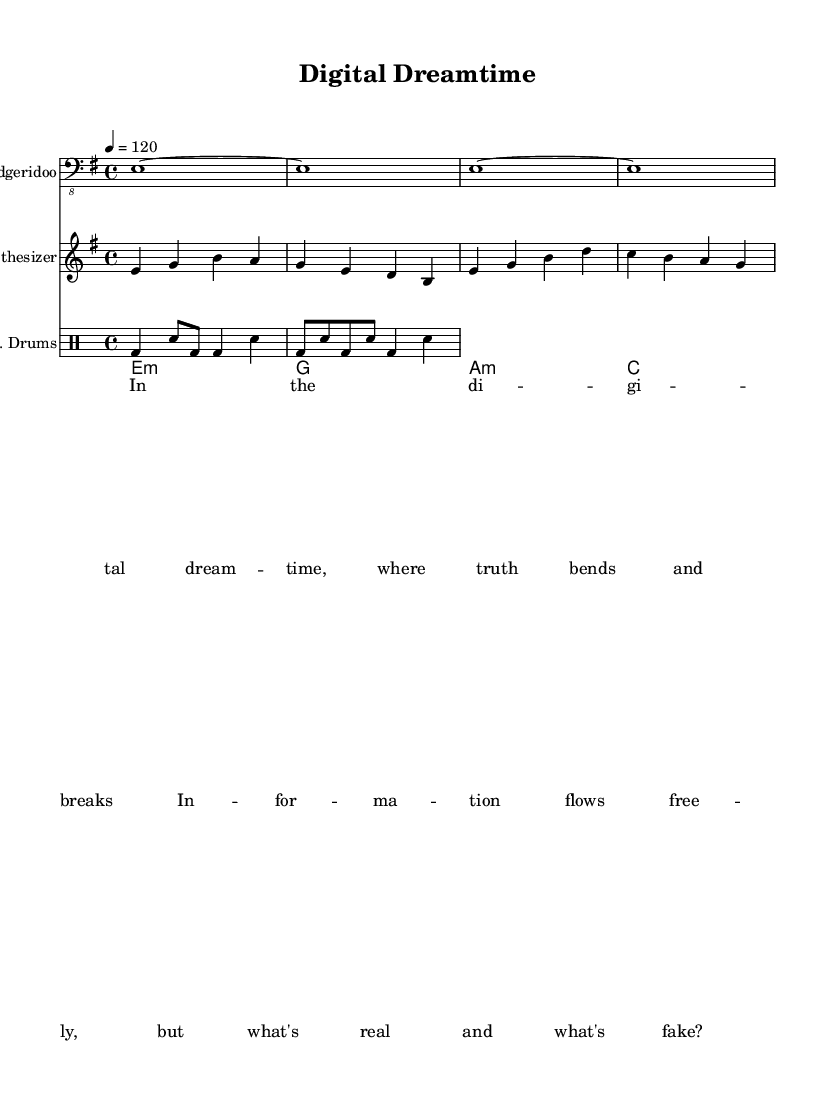What is the key signature of this music? The key signature indicates E minor, which has one sharp (F#) in its scale. It can be found by looking for the key signature marked at the beginning of the staff.
Answer: E minor What is the time signature of the piece? The time signature is shown at the beginning of the score. Here, it is 4/4, meaning there are four beats in each measure and the quarter note gets one beat.
Answer: 4/4 What is the tempo indicated for this music? The tempo marking is present at the beginning of the score, stating '4 = 120'. This means there are 120 beats per minute.
Answer: 120 How many measures does the didgeridoo part have in total? Counting the measures in the didgeridoo section reveals that there are four measures, as each measure is separated by a vertical line.
Answer: 4 What musical elements are present in this piece to signify its genre as World Music? World Music elements are present in the incorporation of the didgeridoo, which is an indigenous Australian instrument, fused with electronic elements like synthesizer sounds. This fusion is characteristic of World Music themes.
Answer: Didgeridoo and synthesizer Which instrument is responsible for the rhythm section? The rhythm section is represented by the E drums, which can be identified in the drum staff. Their specific notation indicates they provide the percussive backing for the other instruments.
Answer: E drums 